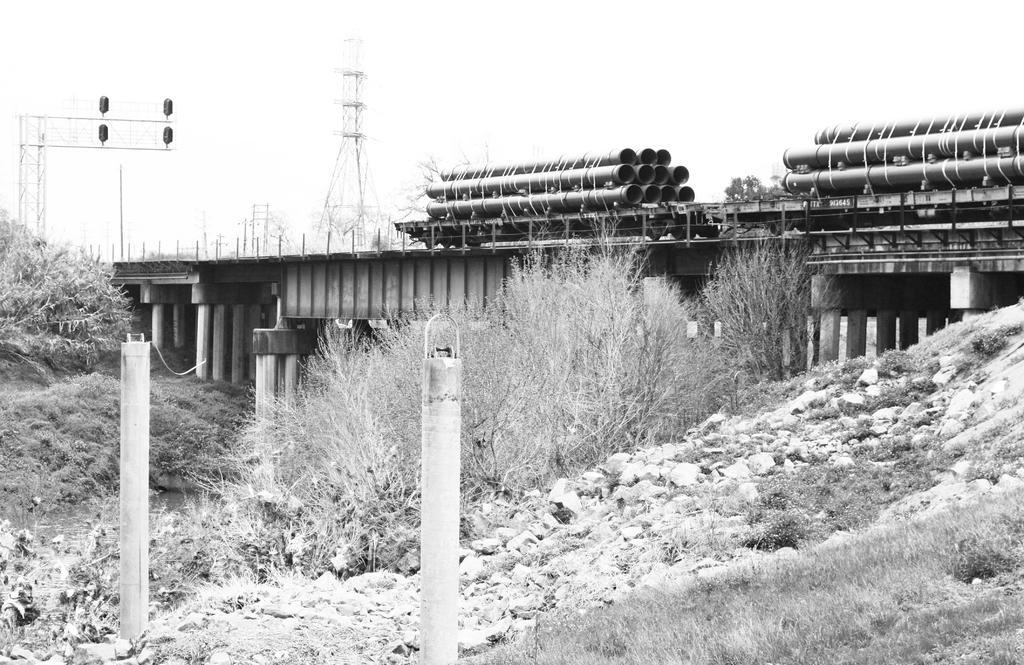Can you describe this image briefly? It is the black and white image in which there is a bridge in the middle. On the bridge there is a truck. On the truck there are pipes which are tied with the ropes. At the bottom there are stones and small plants. In the background there is a tower. On the left side there are signal lights on the road. At the bottom there are two poles. 